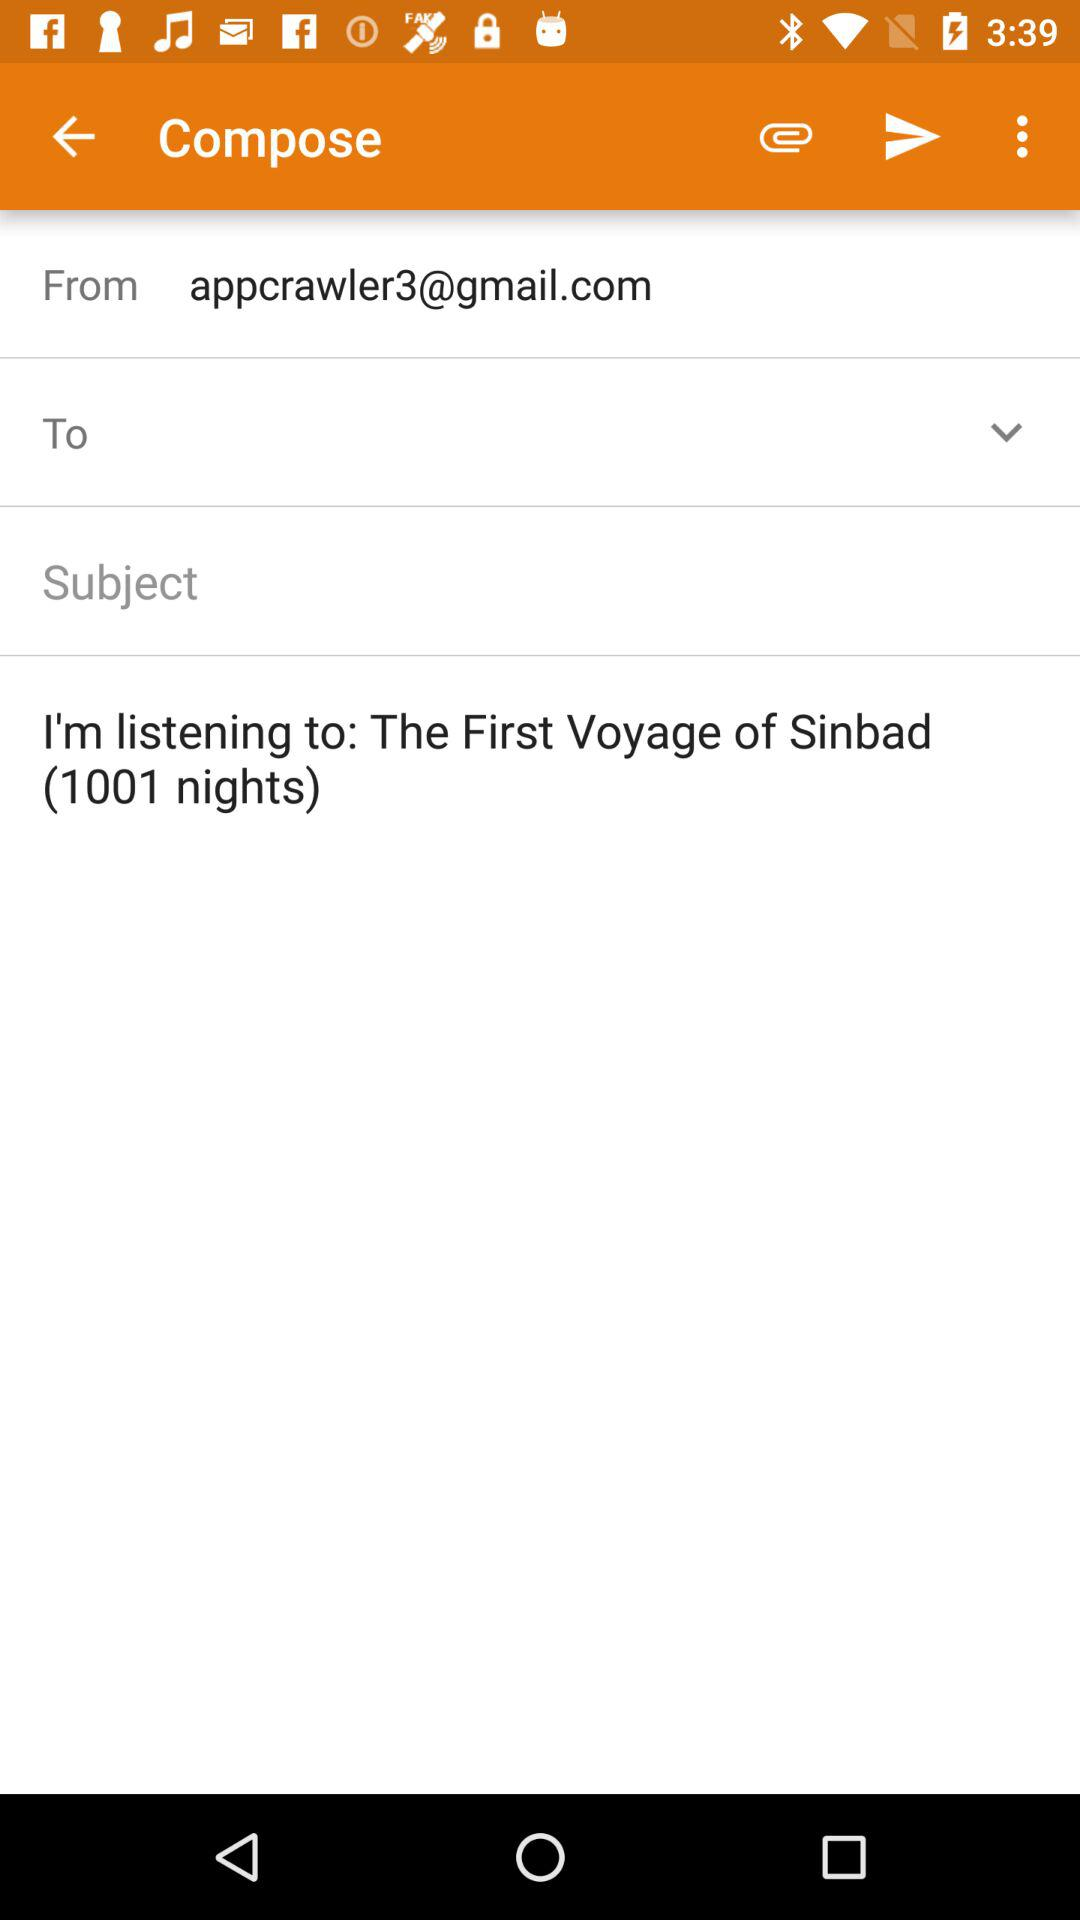What is written in the email? In the email, it is written that "I'm listening to: The First Voyage of Sinbad (1001 nights)". 